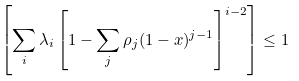Convert formula to latex. <formula><loc_0><loc_0><loc_500><loc_500>\left [ \sum _ { i } \lambda _ { i } \left [ 1 - \sum _ { j } \rho _ { j } ( 1 - x ) ^ { j - 1 } \right ] ^ { i - 2 } \right ] \leq 1</formula> 